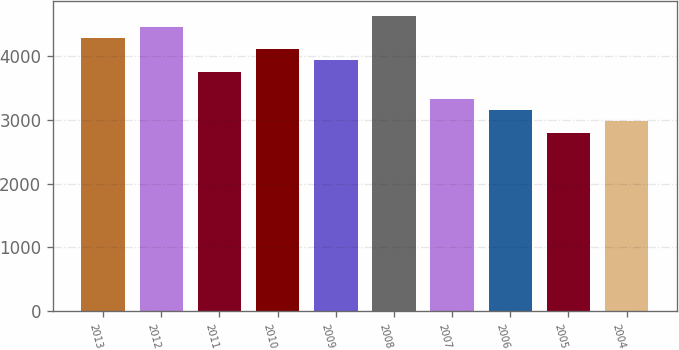Convert chart. <chart><loc_0><loc_0><loc_500><loc_500><bar_chart><fcel>2013<fcel>2012<fcel>2011<fcel>2010<fcel>2009<fcel>2008<fcel>2007<fcel>2006<fcel>2005<fcel>2004<nl><fcel>4286.9<fcel>4463.2<fcel>3758<fcel>4110.6<fcel>3934.3<fcel>4639.5<fcel>3329.9<fcel>3153.6<fcel>2801<fcel>2977.3<nl></chart> 